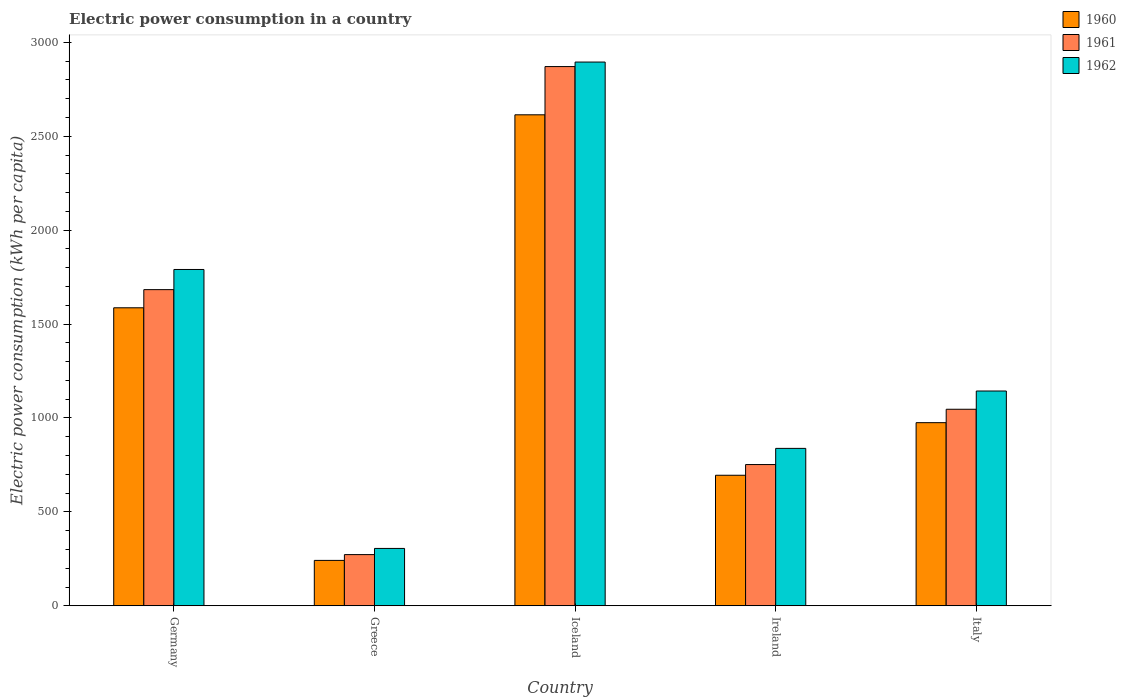How many groups of bars are there?
Your answer should be compact. 5. Are the number of bars per tick equal to the number of legend labels?
Your answer should be very brief. Yes. Are the number of bars on each tick of the X-axis equal?
Provide a short and direct response. Yes. How many bars are there on the 5th tick from the right?
Ensure brevity in your answer.  3. In how many cases, is the number of bars for a given country not equal to the number of legend labels?
Keep it short and to the point. 0. What is the electric power consumption in in 1961 in Greece?
Offer a terse response. 272.56. Across all countries, what is the maximum electric power consumption in in 1960?
Your response must be concise. 2614.28. Across all countries, what is the minimum electric power consumption in in 1962?
Make the answer very short. 305.39. In which country was the electric power consumption in in 1961 maximum?
Offer a very short reply. Iceland. What is the total electric power consumption in in 1961 in the graph?
Provide a succinct answer. 6625.45. What is the difference between the electric power consumption in in 1962 in Greece and that in Italy?
Provide a succinct answer. -838.22. What is the difference between the electric power consumption in in 1960 in Iceland and the electric power consumption in in 1962 in Germany?
Ensure brevity in your answer.  823.6. What is the average electric power consumption in in 1961 per country?
Provide a succinct answer. 1325.09. What is the difference between the electric power consumption in of/in 1960 and electric power consumption in of/in 1962 in Germany?
Your response must be concise. -203.94. What is the ratio of the electric power consumption in in 1962 in Germany to that in Italy?
Ensure brevity in your answer.  1.57. Is the difference between the electric power consumption in in 1960 in Germany and Ireland greater than the difference between the electric power consumption in in 1962 in Germany and Ireland?
Your answer should be very brief. No. What is the difference between the highest and the second highest electric power consumption in in 1961?
Keep it short and to the point. 637. What is the difference between the highest and the lowest electric power consumption in in 1961?
Provide a succinct answer. 2598.48. In how many countries, is the electric power consumption in in 1960 greater than the average electric power consumption in in 1960 taken over all countries?
Provide a succinct answer. 2. What does the 3rd bar from the left in Greece represents?
Your answer should be very brief. 1962. What does the 2nd bar from the right in Greece represents?
Offer a very short reply. 1961. Is it the case that in every country, the sum of the electric power consumption in in 1960 and electric power consumption in in 1962 is greater than the electric power consumption in in 1961?
Your answer should be very brief. Yes. How many bars are there?
Keep it short and to the point. 15. Are all the bars in the graph horizontal?
Give a very brief answer. No. How many countries are there in the graph?
Offer a very short reply. 5. What is the difference between two consecutive major ticks on the Y-axis?
Your answer should be very brief. 500. Are the values on the major ticks of Y-axis written in scientific E-notation?
Give a very brief answer. No. Does the graph contain any zero values?
Ensure brevity in your answer.  No. How many legend labels are there?
Give a very brief answer. 3. How are the legend labels stacked?
Offer a terse response. Vertical. What is the title of the graph?
Offer a very short reply. Electric power consumption in a country. What is the label or title of the Y-axis?
Give a very brief answer. Electric power consumption (kWh per capita). What is the Electric power consumption (kWh per capita) of 1960 in Germany?
Your answer should be compact. 1586.75. What is the Electric power consumption (kWh per capita) in 1961 in Germany?
Your answer should be very brief. 1683.41. What is the Electric power consumption (kWh per capita) of 1962 in Germany?
Your response must be concise. 1790.69. What is the Electric power consumption (kWh per capita) in 1960 in Greece?
Your answer should be compact. 241.73. What is the Electric power consumption (kWh per capita) of 1961 in Greece?
Your answer should be very brief. 272.56. What is the Electric power consumption (kWh per capita) in 1962 in Greece?
Provide a short and direct response. 305.39. What is the Electric power consumption (kWh per capita) of 1960 in Iceland?
Your response must be concise. 2614.28. What is the Electric power consumption (kWh per capita) in 1961 in Iceland?
Give a very brief answer. 2871.04. What is the Electric power consumption (kWh per capita) of 1962 in Iceland?
Offer a terse response. 2895.09. What is the Electric power consumption (kWh per capita) in 1960 in Ireland?
Your answer should be compact. 695.04. What is the Electric power consumption (kWh per capita) of 1961 in Ireland?
Keep it short and to the point. 752.02. What is the Electric power consumption (kWh per capita) of 1962 in Ireland?
Keep it short and to the point. 838.14. What is the Electric power consumption (kWh per capita) of 1960 in Italy?
Make the answer very short. 975.03. What is the Electric power consumption (kWh per capita) in 1961 in Italy?
Ensure brevity in your answer.  1046.42. What is the Electric power consumption (kWh per capita) in 1962 in Italy?
Make the answer very short. 1143.61. Across all countries, what is the maximum Electric power consumption (kWh per capita) of 1960?
Make the answer very short. 2614.28. Across all countries, what is the maximum Electric power consumption (kWh per capita) in 1961?
Your answer should be compact. 2871.04. Across all countries, what is the maximum Electric power consumption (kWh per capita) in 1962?
Make the answer very short. 2895.09. Across all countries, what is the minimum Electric power consumption (kWh per capita) in 1960?
Keep it short and to the point. 241.73. Across all countries, what is the minimum Electric power consumption (kWh per capita) of 1961?
Provide a succinct answer. 272.56. Across all countries, what is the minimum Electric power consumption (kWh per capita) of 1962?
Offer a terse response. 305.39. What is the total Electric power consumption (kWh per capita) of 1960 in the graph?
Give a very brief answer. 6112.83. What is the total Electric power consumption (kWh per capita) of 1961 in the graph?
Offer a very short reply. 6625.45. What is the total Electric power consumption (kWh per capita) of 1962 in the graph?
Provide a succinct answer. 6972.9. What is the difference between the Electric power consumption (kWh per capita) in 1960 in Germany and that in Greece?
Offer a very short reply. 1345.02. What is the difference between the Electric power consumption (kWh per capita) in 1961 in Germany and that in Greece?
Make the answer very short. 1410.85. What is the difference between the Electric power consumption (kWh per capita) of 1962 in Germany and that in Greece?
Make the answer very short. 1485.3. What is the difference between the Electric power consumption (kWh per capita) of 1960 in Germany and that in Iceland?
Make the answer very short. -1027.53. What is the difference between the Electric power consumption (kWh per capita) in 1961 in Germany and that in Iceland?
Offer a very short reply. -1187.63. What is the difference between the Electric power consumption (kWh per capita) of 1962 in Germany and that in Iceland?
Make the answer very short. -1104.4. What is the difference between the Electric power consumption (kWh per capita) of 1960 in Germany and that in Ireland?
Your answer should be very brief. 891.71. What is the difference between the Electric power consumption (kWh per capita) of 1961 in Germany and that in Ireland?
Ensure brevity in your answer.  931.4. What is the difference between the Electric power consumption (kWh per capita) of 1962 in Germany and that in Ireland?
Offer a terse response. 952.55. What is the difference between the Electric power consumption (kWh per capita) of 1960 in Germany and that in Italy?
Keep it short and to the point. 611.72. What is the difference between the Electric power consumption (kWh per capita) of 1961 in Germany and that in Italy?
Your response must be concise. 637. What is the difference between the Electric power consumption (kWh per capita) of 1962 in Germany and that in Italy?
Provide a succinct answer. 647.08. What is the difference between the Electric power consumption (kWh per capita) in 1960 in Greece and that in Iceland?
Offer a very short reply. -2372.56. What is the difference between the Electric power consumption (kWh per capita) of 1961 in Greece and that in Iceland?
Your answer should be compact. -2598.48. What is the difference between the Electric power consumption (kWh per capita) of 1962 in Greece and that in Iceland?
Your response must be concise. -2589.7. What is the difference between the Electric power consumption (kWh per capita) in 1960 in Greece and that in Ireland?
Offer a very short reply. -453.32. What is the difference between the Electric power consumption (kWh per capita) of 1961 in Greece and that in Ireland?
Your answer should be compact. -479.45. What is the difference between the Electric power consumption (kWh per capita) of 1962 in Greece and that in Ireland?
Provide a short and direct response. -532.75. What is the difference between the Electric power consumption (kWh per capita) of 1960 in Greece and that in Italy?
Offer a terse response. -733.3. What is the difference between the Electric power consumption (kWh per capita) of 1961 in Greece and that in Italy?
Ensure brevity in your answer.  -773.85. What is the difference between the Electric power consumption (kWh per capita) of 1962 in Greece and that in Italy?
Give a very brief answer. -838.22. What is the difference between the Electric power consumption (kWh per capita) in 1960 in Iceland and that in Ireland?
Provide a succinct answer. 1919.24. What is the difference between the Electric power consumption (kWh per capita) of 1961 in Iceland and that in Ireland?
Ensure brevity in your answer.  2119.03. What is the difference between the Electric power consumption (kWh per capita) in 1962 in Iceland and that in Ireland?
Provide a short and direct response. 2056.95. What is the difference between the Electric power consumption (kWh per capita) in 1960 in Iceland and that in Italy?
Your answer should be very brief. 1639.26. What is the difference between the Electric power consumption (kWh per capita) of 1961 in Iceland and that in Italy?
Your answer should be compact. 1824.63. What is the difference between the Electric power consumption (kWh per capita) of 1962 in Iceland and that in Italy?
Ensure brevity in your answer.  1751.48. What is the difference between the Electric power consumption (kWh per capita) of 1960 in Ireland and that in Italy?
Your answer should be very brief. -279.98. What is the difference between the Electric power consumption (kWh per capita) of 1961 in Ireland and that in Italy?
Provide a short and direct response. -294.4. What is the difference between the Electric power consumption (kWh per capita) in 1962 in Ireland and that in Italy?
Keep it short and to the point. -305.47. What is the difference between the Electric power consumption (kWh per capita) of 1960 in Germany and the Electric power consumption (kWh per capita) of 1961 in Greece?
Offer a very short reply. 1314.19. What is the difference between the Electric power consumption (kWh per capita) in 1960 in Germany and the Electric power consumption (kWh per capita) in 1962 in Greece?
Your answer should be compact. 1281.36. What is the difference between the Electric power consumption (kWh per capita) of 1961 in Germany and the Electric power consumption (kWh per capita) of 1962 in Greece?
Your response must be concise. 1378.03. What is the difference between the Electric power consumption (kWh per capita) of 1960 in Germany and the Electric power consumption (kWh per capita) of 1961 in Iceland?
Make the answer very short. -1284.29. What is the difference between the Electric power consumption (kWh per capita) in 1960 in Germany and the Electric power consumption (kWh per capita) in 1962 in Iceland?
Provide a short and direct response. -1308.34. What is the difference between the Electric power consumption (kWh per capita) of 1961 in Germany and the Electric power consumption (kWh per capita) of 1962 in Iceland?
Ensure brevity in your answer.  -1211.67. What is the difference between the Electric power consumption (kWh per capita) in 1960 in Germany and the Electric power consumption (kWh per capita) in 1961 in Ireland?
Provide a succinct answer. 834.73. What is the difference between the Electric power consumption (kWh per capita) in 1960 in Germany and the Electric power consumption (kWh per capita) in 1962 in Ireland?
Give a very brief answer. 748.61. What is the difference between the Electric power consumption (kWh per capita) in 1961 in Germany and the Electric power consumption (kWh per capita) in 1962 in Ireland?
Your answer should be very brief. 845.28. What is the difference between the Electric power consumption (kWh per capita) in 1960 in Germany and the Electric power consumption (kWh per capita) in 1961 in Italy?
Keep it short and to the point. 540.33. What is the difference between the Electric power consumption (kWh per capita) in 1960 in Germany and the Electric power consumption (kWh per capita) in 1962 in Italy?
Your answer should be very brief. 443.14. What is the difference between the Electric power consumption (kWh per capita) of 1961 in Germany and the Electric power consumption (kWh per capita) of 1962 in Italy?
Your answer should be very brief. 539.81. What is the difference between the Electric power consumption (kWh per capita) in 1960 in Greece and the Electric power consumption (kWh per capita) in 1961 in Iceland?
Your answer should be compact. -2629.32. What is the difference between the Electric power consumption (kWh per capita) in 1960 in Greece and the Electric power consumption (kWh per capita) in 1962 in Iceland?
Give a very brief answer. -2653.36. What is the difference between the Electric power consumption (kWh per capita) in 1961 in Greece and the Electric power consumption (kWh per capita) in 1962 in Iceland?
Your answer should be compact. -2622.52. What is the difference between the Electric power consumption (kWh per capita) in 1960 in Greece and the Electric power consumption (kWh per capita) in 1961 in Ireland?
Provide a short and direct response. -510.29. What is the difference between the Electric power consumption (kWh per capita) in 1960 in Greece and the Electric power consumption (kWh per capita) in 1962 in Ireland?
Keep it short and to the point. -596.41. What is the difference between the Electric power consumption (kWh per capita) in 1961 in Greece and the Electric power consumption (kWh per capita) in 1962 in Ireland?
Ensure brevity in your answer.  -565.57. What is the difference between the Electric power consumption (kWh per capita) of 1960 in Greece and the Electric power consumption (kWh per capita) of 1961 in Italy?
Make the answer very short. -804.69. What is the difference between the Electric power consumption (kWh per capita) of 1960 in Greece and the Electric power consumption (kWh per capita) of 1962 in Italy?
Provide a succinct answer. -901.88. What is the difference between the Electric power consumption (kWh per capita) in 1961 in Greece and the Electric power consumption (kWh per capita) in 1962 in Italy?
Offer a very short reply. -871.04. What is the difference between the Electric power consumption (kWh per capita) of 1960 in Iceland and the Electric power consumption (kWh per capita) of 1961 in Ireland?
Give a very brief answer. 1862.26. What is the difference between the Electric power consumption (kWh per capita) in 1960 in Iceland and the Electric power consumption (kWh per capita) in 1962 in Ireland?
Your answer should be very brief. 1776.14. What is the difference between the Electric power consumption (kWh per capita) in 1961 in Iceland and the Electric power consumption (kWh per capita) in 1962 in Ireland?
Your answer should be very brief. 2032.91. What is the difference between the Electric power consumption (kWh per capita) in 1960 in Iceland and the Electric power consumption (kWh per capita) in 1961 in Italy?
Your answer should be very brief. 1567.87. What is the difference between the Electric power consumption (kWh per capita) of 1960 in Iceland and the Electric power consumption (kWh per capita) of 1962 in Italy?
Make the answer very short. 1470.68. What is the difference between the Electric power consumption (kWh per capita) in 1961 in Iceland and the Electric power consumption (kWh per capita) in 1962 in Italy?
Give a very brief answer. 1727.44. What is the difference between the Electric power consumption (kWh per capita) in 1960 in Ireland and the Electric power consumption (kWh per capita) in 1961 in Italy?
Ensure brevity in your answer.  -351.37. What is the difference between the Electric power consumption (kWh per capita) in 1960 in Ireland and the Electric power consumption (kWh per capita) in 1962 in Italy?
Provide a succinct answer. -448.56. What is the difference between the Electric power consumption (kWh per capita) of 1961 in Ireland and the Electric power consumption (kWh per capita) of 1962 in Italy?
Make the answer very short. -391.59. What is the average Electric power consumption (kWh per capita) in 1960 per country?
Offer a very short reply. 1222.57. What is the average Electric power consumption (kWh per capita) in 1961 per country?
Offer a terse response. 1325.09. What is the average Electric power consumption (kWh per capita) of 1962 per country?
Your answer should be compact. 1394.58. What is the difference between the Electric power consumption (kWh per capita) in 1960 and Electric power consumption (kWh per capita) in 1961 in Germany?
Keep it short and to the point. -96.67. What is the difference between the Electric power consumption (kWh per capita) of 1960 and Electric power consumption (kWh per capita) of 1962 in Germany?
Ensure brevity in your answer.  -203.94. What is the difference between the Electric power consumption (kWh per capita) in 1961 and Electric power consumption (kWh per capita) in 1962 in Germany?
Offer a very short reply. -107.27. What is the difference between the Electric power consumption (kWh per capita) of 1960 and Electric power consumption (kWh per capita) of 1961 in Greece?
Give a very brief answer. -30.84. What is the difference between the Electric power consumption (kWh per capita) of 1960 and Electric power consumption (kWh per capita) of 1962 in Greece?
Give a very brief answer. -63.66. What is the difference between the Electric power consumption (kWh per capita) of 1961 and Electric power consumption (kWh per capita) of 1962 in Greece?
Keep it short and to the point. -32.83. What is the difference between the Electric power consumption (kWh per capita) in 1960 and Electric power consumption (kWh per capita) in 1961 in Iceland?
Ensure brevity in your answer.  -256.76. What is the difference between the Electric power consumption (kWh per capita) of 1960 and Electric power consumption (kWh per capita) of 1962 in Iceland?
Your answer should be very brief. -280.8. What is the difference between the Electric power consumption (kWh per capita) in 1961 and Electric power consumption (kWh per capita) in 1962 in Iceland?
Make the answer very short. -24.04. What is the difference between the Electric power consumption (kWh per capita) in 1960 and Electric power consumption (kWh per capita) in 1961 in Ireland?
Keep it short and to the point. -56.97. What is the difference between the Electric power consumption (kWh per capita) of 1960 and Electric power consumption (kWh per capita) of 1962 in Ireland?
Your answer should be very brief. -143.09. What is the difference between the Electric power consumption (kWh per capita) of 1961 and Electric power consumption (kWh per capita) of 1962 in Ireland?
Give a very brief answer. -86.12. What is the difference between the Electric power consumption (kWh per capita) in 1960 and Electric power consumption (kWh per capita) in 1961 in Italy?
Offer a terse response. -71.39. What is the difference between the Electric power consumption (kWh per capita) in 1960 and Electric power consumption (kWh per capita) in 1962 in Italy?
Offer a very short reply. -168.58. What is the difference between the Electric power consumption (kWh per capita) in 1961 and Electric power consumption (kWh per capita) in 1962 in Italy?
Offer a terse response. -97.19. What is the ratio of the Electric power consumption (kWh per capita) of 1960 in Germany to that in Greece?
Make the answer very short. 6.56. What is the ratio of the Electric power consumption (kWh per capita) in 1961 in Germany to that in Greece?
Provide a short and direct response. 6.18. What is the ratio of the Electric power consumption (kWh per capita) of 1962 in Germany to that in Greece?
Keep it short and to the point. 5.86. What is the ratio of the Electric power consumption (kWh per capita) in 1960 in Germany to that in Iceland?
Provide a short and direct response. 0.61. What is the ratio of the Electric power consumption (kWh per capita) in 1961 in Germany to that in Iceland?
Your answer should be very brief. 0.59. What is the ratio of the Electric power consumption (kWh per capita) of 1962 in Germany to that in Iceland?
Ensure brevity in your answer.  0.62. What is the ratio of the Electric power consumption (kWh per capita) of 1960 in Germany to that in Ireland?
Make the answer very short. 2.28. What is the ratio of the Electric power consumption (kWh per capita) in 1961 in Germany to that in Ireland?
Offer a very short reply. 2.24. What is the ratio of the Electric power consumption (kWh per capita) in 1962 in Germany to that in Ireland?
Make the answer very short. 2.14. What is the ratio of the Electric power consumption (kWh per capita) in 1960 in Germany to that in Italy?
Offer a terse response. 1.63. What is the ratio of the Electric power consumption (kWh per capita) in 1961 in Germany to that in Italy?
Your response must be concise. 1.61. What is the ratio of the Electric power consumption (kWh per capita) in 1962 in Germany to that in Italy?
Offer a terse response. 1.57. What is the ratio of the Electric power consumption (kWh per capita) of 1960 in Greece to that in Iceland?
Offer a very short reply. 0.09. What is the ratio of the Electric power consumption (kWh per capita) in 1961 in Greece to that in Iceland?
Provide a succinct answer. 0.09. What is the ratio of the Electric power consumption (kWh per capita) of 1962 in Greece to that in Iceland?
Provide a short and direct response. 0.11. What is the ratio of the Electric power consumption (kWh per capita) of 1960 in Greece to that in Ireland?
Keep it short and to the point. 0.35. What is the ratio of the Electric power consumption (kWh per capita) of 1961 in Greece to that in Ireland?
Offer a terse response. 0.36. What is the ratio of the Electric power consumption (kWh per capita) of 1962 in Greece to that in Ireland?
Provide a short and direct response. 0.36. What is the ratio of the Electric power consumption (kWh per capita) in 1960 in Greece to that in Italy?
Your response must be concise. 0.25. What is the ratio of the Electric power consumption (kWh per capita) of 1961 in Greece to that in Italy?
Ensure brevity in your answer.  0.26. What is the ratio of the Electric power consumption (kWh per capita) in 1962 in Greece to that in Italy?
Provide a short and direct response. 0.27. What is the ratio of the Electric power consumption (kWh per capita) in 1960 in Iceland to that in Ireland?
Ensure brevity in your answer.  3.76. What is the ratio of the Electric power consumption (kWh per capita) of 1961 in Iceland to that in Ireland?
Offer a terse response. 3.82. What is the ratio of the Electric power consumption (kWh per capita) of 1962 in Iceland to that in Ireland?
Your answer should be compact. 3.45. What is the ratio of the Electric power consumption (kWh per capita) of 1960 in Iceland to that in Italy?
Your answer should be compact. 2.68. What is the ratio of the Electric power consumption (kWh per capita) in 1961 in Iceland to that in Italy?
Make the answer very short. 2.74. What is the ratio of the Electric power consumption (kWh per capita) of 1962 in Iceland to that in Italy?
Give a very brief answer. 2.53. What is the ratio of the Electric power consumption (kWh per capita) in 1960 in Ireland to that in Italy?
Offer a very short reply. 0.71. What is the ratio of the Electric power consumption (kWh per capita) of 1961 in Ireland to that in Italy?
Your answer should be very brief. 0.72. What is the ratio of the Electric power consumption (kWh per capita) in 1962 in Ireland to that in Italy?
Provide a succinct answer. 0.73. What is the difference between the highest and the second highest Electric power consumption (kWh per capita) in 1960?
Give a very brief answer. 1027.53. What is the difference between the highest and the second highest Electric power consumption (kWh per capita) in 1961?
Give a very brief answer. 1187.63. What is the difference between the highest and the second highest Electric power consumption (kWh per capita) of 1962?
Make the answer very short. 1104.4. What is the difference between the highest and the lowest Electric power consumption (kWh per capita) in 1960?
Provide a short and direct response. 2372.56. What is the difference between the highest and the lowest Electric power consumption (kWh per capita) in 1961?
Offer a very short reply. 2598.48. What is the difference between the highest and the lowest Electric power consumption (kWh per capita) in 1962?
Provide a succinct answer. 2589.7. 